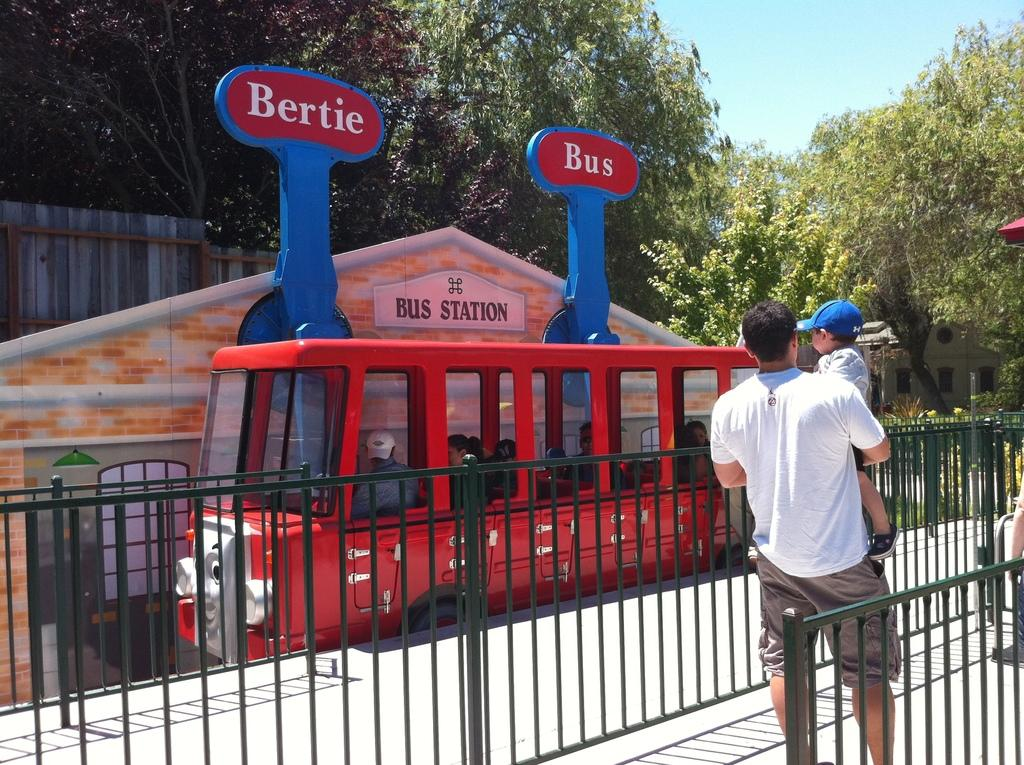What is the person in the image doing? The person is carrying a child in the image. What can be seen in the background of the image? There is a red color bus in the image, and there are trees and plants around the bus. What is inside the bus? There are people inside the bus. How many boxes can be seen in the image? There are no boxes present in the image. What type of destruction is happening in the image? There is no destruction present in the image; it shows a person carrying a child and a bus with people inside. 